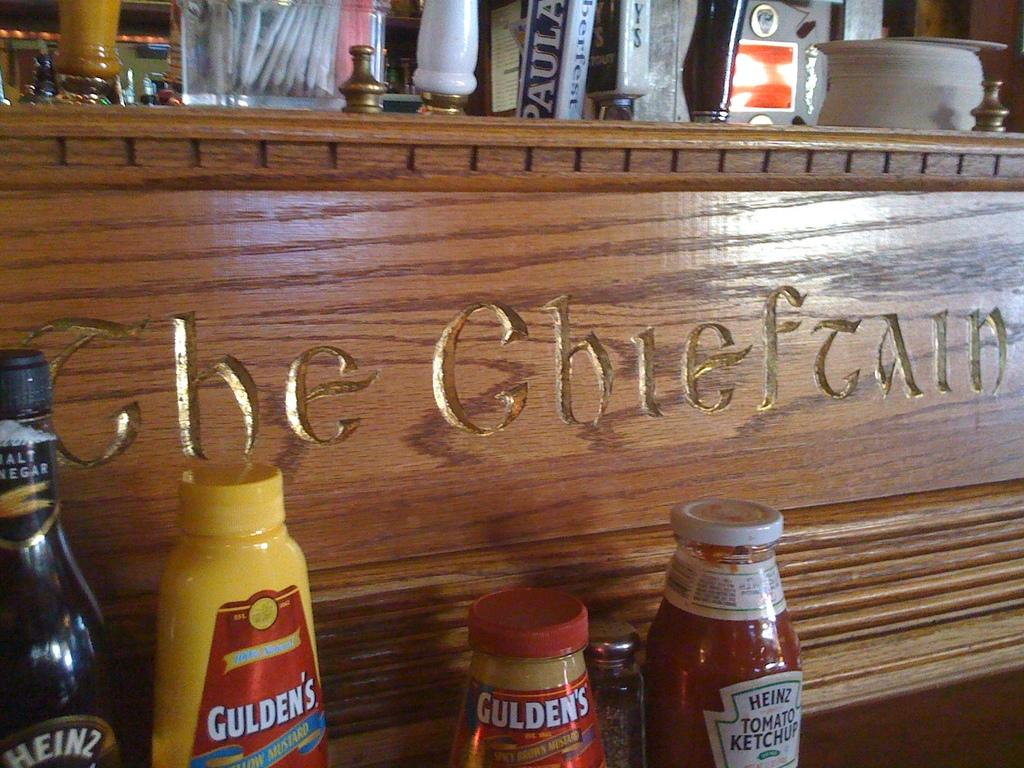What is the main object in the image? There is a wine bottle in the image. Are there any other bottles present? Yes, there are other bottles in the image. Where are the bottles located? The bottles are on a wooden board. What type of invention can be seen in the image? There is no invention present in the image; it features bottles on a wooden board. 